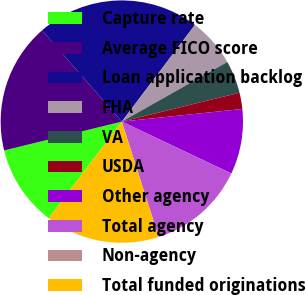Convert chart to OTSL. <chart><loc_0><loc_0><loc_500><loc_500><pie_chart><fcel>Capture rate<fcel>Average FICO score<fcel>Loan application backlog<fcel>FHA<fcel>VA<fcel>USDA<fcel>Other agency<fcel>Total agency<fcel>Non-agency<fcel>Total funded originations<nl><fcel>10.87%<fcel>17.39%<fcel>21.74%<fcel>6.52%<fcel>4.35%<fcel>2.17%<fcel>8.7%<fcel>13.04%<fcel>0.0%<fcel>15.22%<nl></chart> 